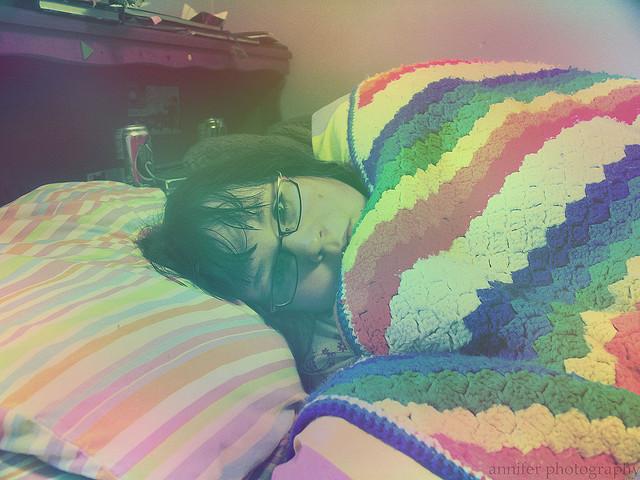What colors are in the blanket?
Keep it brief. Rainbow. What is the lady laying her head on?
Short answer required. Pillow. Is the blanket colorful?
Write a very short answer. Yes. 